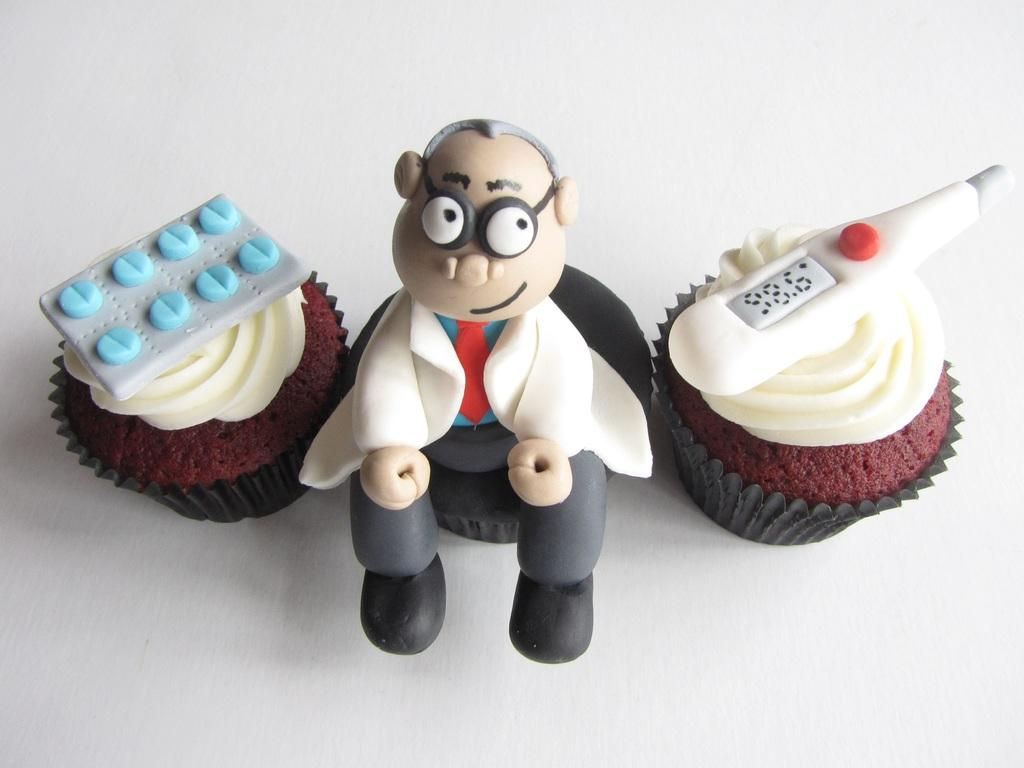What type of desserts can be seen in the image? There are cupcakes placed on a surface, as well as cakes in various shapes. Can you describe the shapes of the cakes in the image? There is a cake in the shape of a tablet, a cake in the shape of a person, and a cake in the shape of a thermometer. What advice does the friend give to the manager about the cake development in the image? There is no friend or manager present in the image, nor is there any indication of a development process for the cakes. 